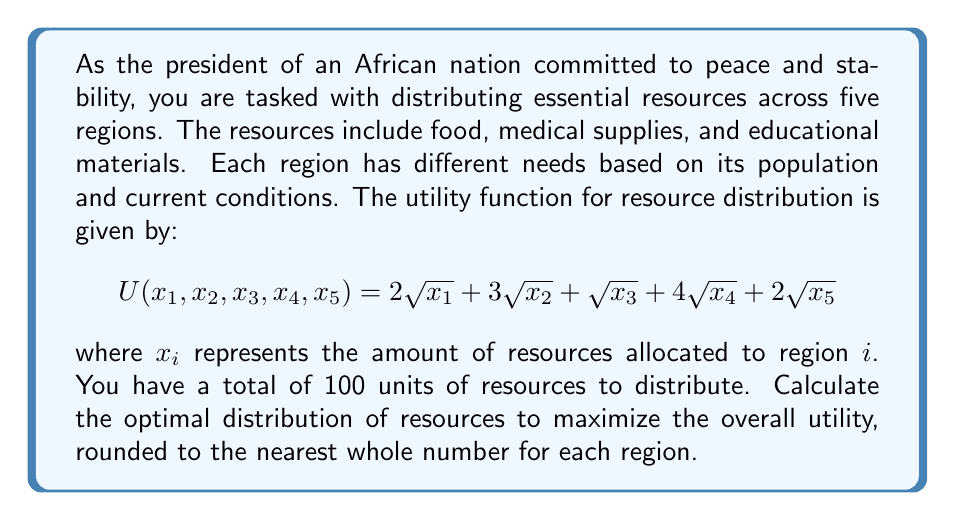Help me with this question. To solve this optimization problem, we can use the method of Lagrange multipliers:

1) First, we set up the Lagrangian function:
   $$L(x_1, x_2, x_3, x_4, x_5, \lambda) = 2\sqrt{x_1} + 3\sqrt{x_2} + \sqrt{x_3} + 4\sqrt{x_4} + 2\sqrt{x_5} - \lambda(x_1 + x_2 + x_3 + x_4 + x_5 - 100)$$

2) We then take partial derivatives with respect to each variable and set them equal to zero:
   $$\frac{\partial L}{\partial x_1} = \frac{1}{\sqrt{x_1}} - \lambda = 0$$
   $$\frac{\partial L}{\partial x_2} = \frac{3}{2\sqrt{x_2}} - \lambda = 0$$
   $$\frac{\partial L}{\partial x_3} = \frac{1}{2\sqrt{x_3}} - \lambda = 0$$
   $$\frac{\partial L}{\partial x_4} = \frac{2}{\sqrt{x_4}} - \lambda = 0$$
   $$\frac{\partial L}{\partial x_5} = \frac{1}{\sqrt{x_5}} - \lambda = 0$$
   $$\frac{\partial L}{\partial \lambda} = x_1 + x_2 + x_3 + x_4 + x_5 - 100 = 0$$

3) From these equations, we can derive the following relationships:
   $$x_1 = 4x_3, x_2 = 36x_3, x_4 = 16x_3, x_5 = 4x_3$$

4) Substituting these into the constraint equation:
   $$4x_3 + 36x_3 + x_3 + 16x_3 + 4x_3 = 100$$
   $$61x_3 = 100$$
   $$x_3 = \frac{100}{61}$$

5) We can now solve for the other variables:
   $$x_1 = 4 \cdot \frac{100}{61} \approx 6.56$$
   $$x_2 = 36 \cdot \frac{100}{61} \approx 59.02$$
   $$x_3 = \frac{100}{61} \approx 1.64$$
   $$x_4 = 16 \cdot \frac{100}{61} \approx 26.23$$
   $$x_5 = 4 \cdot \frac{100}{61} \approx 6.56$$

6) Rounding to the nearest whole number:
   $$x_1 = 7, x_2 = 59, x_3 = 2, x_4 = 26, x_5 = 7$$
Answer: The optimal distribution of resources across the five regions, rounded to the nearest whole number, is:
Region 1: 7 units
Region 2: 59 units
Region 3: 2 units
Region 4: 26 units
Region 5: 7 units 